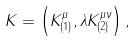<formula> <loc_0><loc_0><loc_500><loc_500>K = \left ( K ^ { \mu } _ { ( 1 ) } , \lambda K ^ { \mu \nu } _ { ( 2 ) } \right ) ,</formula> 